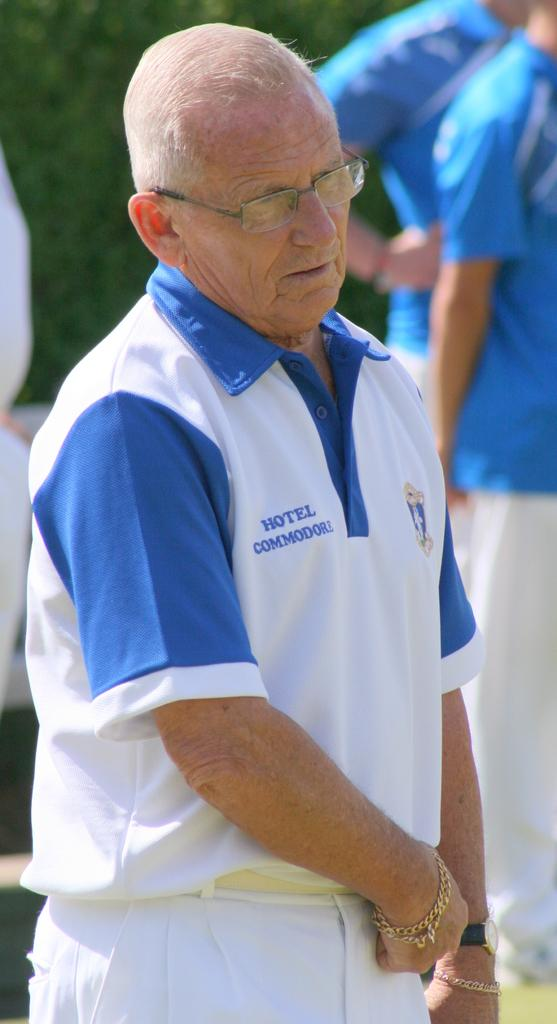<image>
Create a compact narrative representing the image presented. A man wearing a Hotel Commodore shirt stands among other men. 